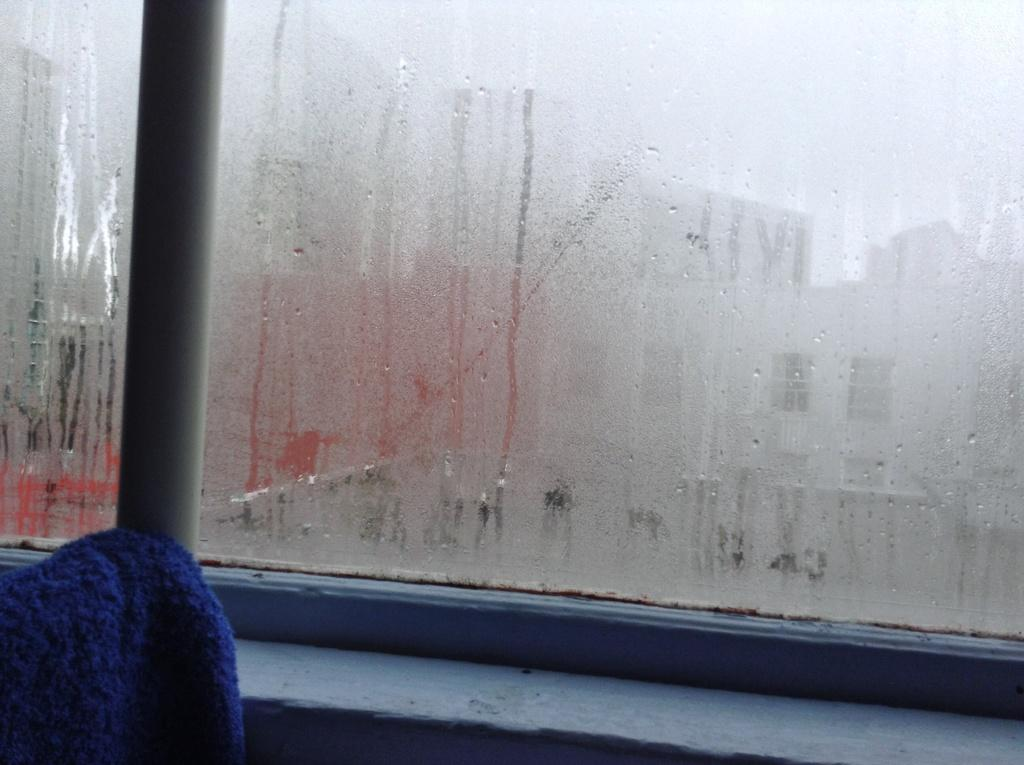What can be seen in the image related to a source of light or air? There is a window in the image. What is the condition of the window in the image? The window has water droplets on it. What is placed in front of the window in the image? There is a blue cloth in front of the window. What type of interest is the rabbit paying to the whip in the image? There is no rabbit or whip present in the image. 